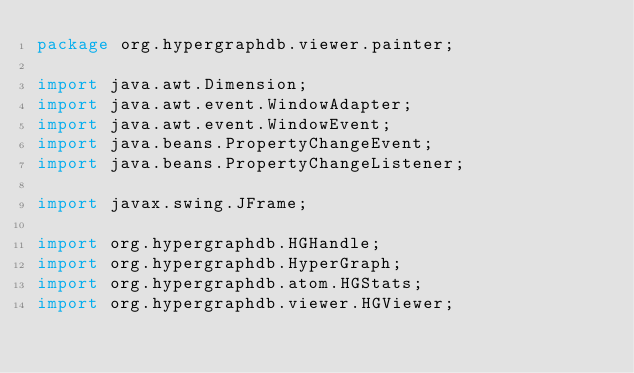Convert code to text. <code><loc_0><loc_0><loc_500><loc_500><_Java_>package org.hypergraphdb.viewer.painter;

import java.awt.Dimension;
import java.awt.event.WindowAdapter;
import java.awt.event.WindowEvent;
import java.beans.PropertyChangeEvent;
import java.beans.PropertyChangeListener;

import javax.swing.JFrame;

import org.hypergraphdb.HGHandle;
import org.hypergraphdb.HyperGraph;
import org.hypergraphdb.atom.HGStats;
import org.hypergraphdb.viewer.HGViewer;
</code> 